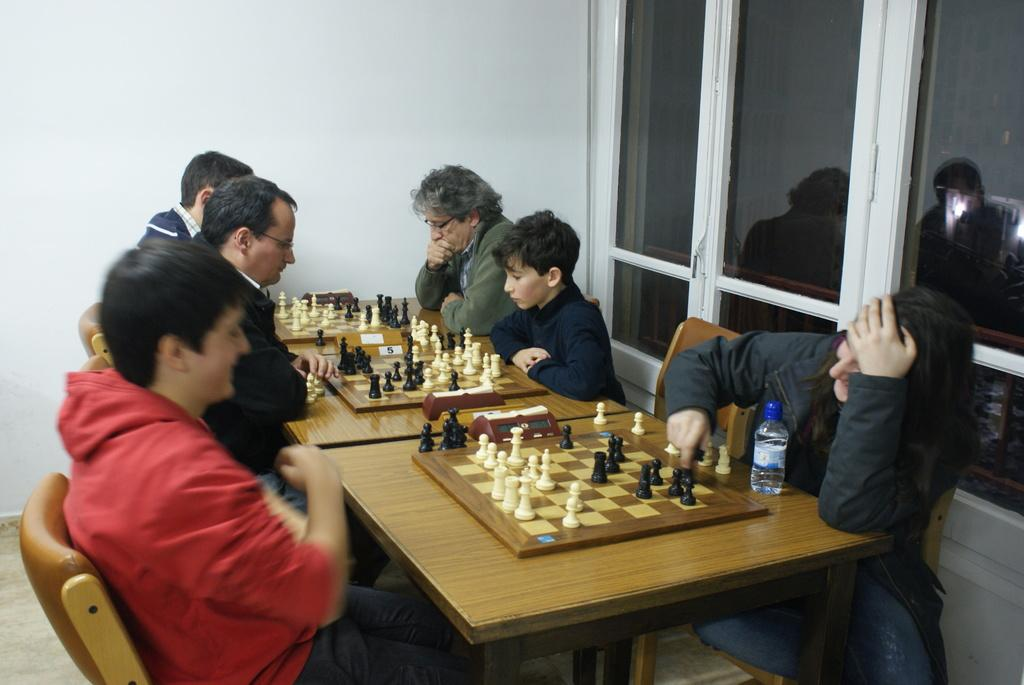How many people are present in the image? There are six people in the image. What activity are the people engaged in? The people are playing chess. What type of furniture are the people using while playing chess? The people are sitting on chairs. What type of governor is being used by the people in the image? There is no governor present in the image; the people are playing chess. 